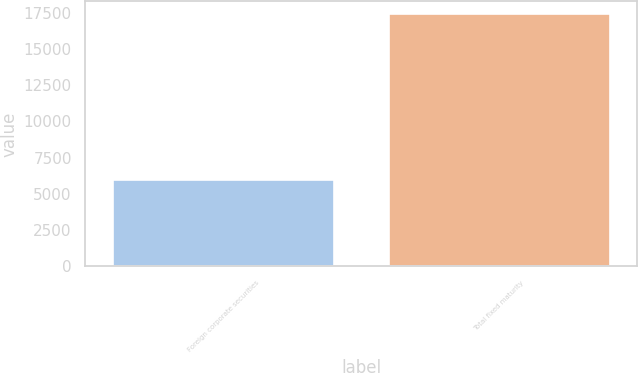Convert chart to OTSL. <chart><loc_0><loc_0><loc_500><loc_500><bar_chart><fcel>Foreign corporate securities<fcel>Total fixed maturity<nl><fcel>5944<fcel>17408<nl></chart> 